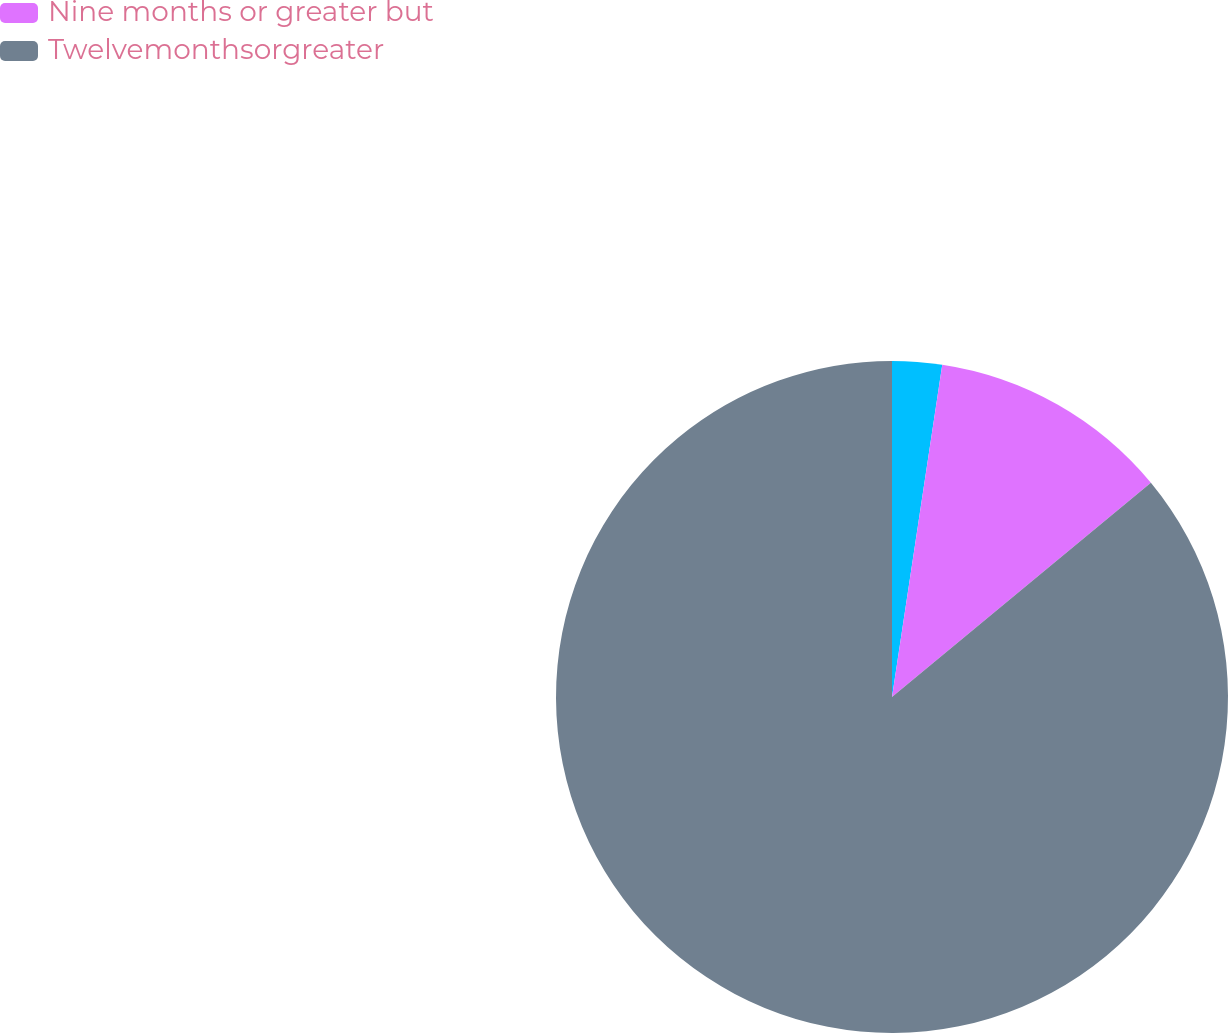<chart> <loc_0><loc_0><loc_500><loc_500><pie_chart><ecel><fcel>Nine months or greater but<fcel>Twelvemonthsorgreater<nl><fcel>2.39%<fcel>11.61%<fcel>86.0%<nl></chart> 